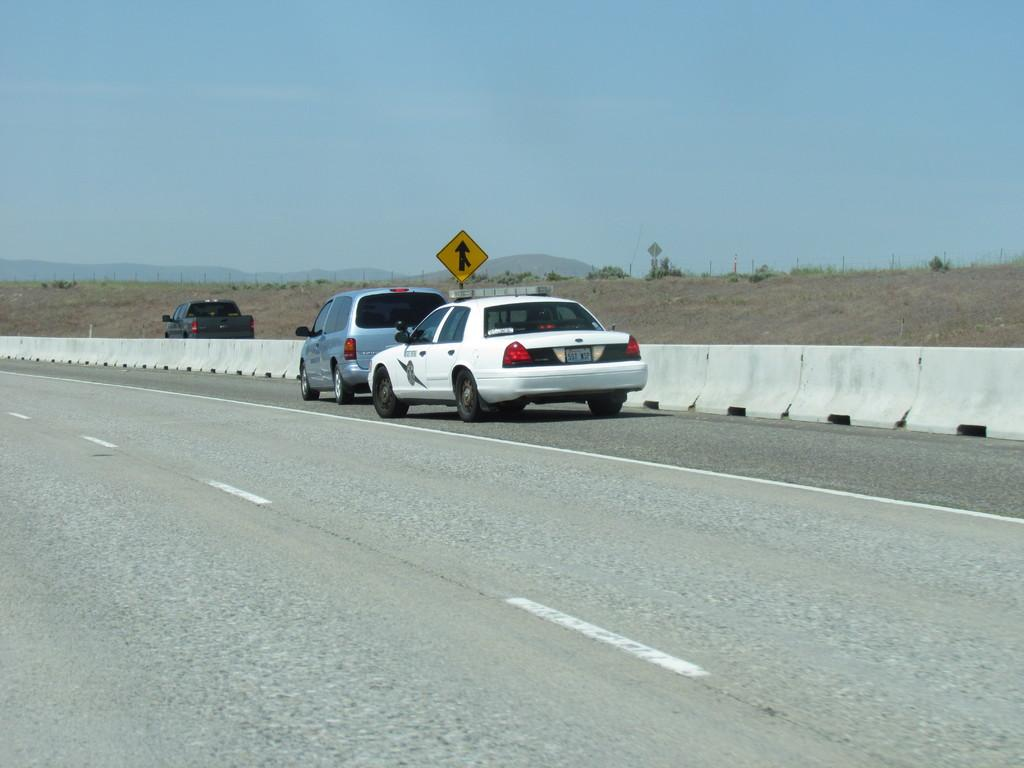What can be seen in the background of the image? There is sky visible in the background of the image, along with hills. What is present on the road in the image? There are vehicles on the road in the image. What safety measures are in place on the road? There is a divider on the road with barricades in the image. What type of sign is present in the image? There is a yellow board in the image. What type of song is being sung by the hands in the image? There are no hands or singing present in the image. How many ducks can be seen swimming in the water in the image? There is no water or ducks present in the image. 